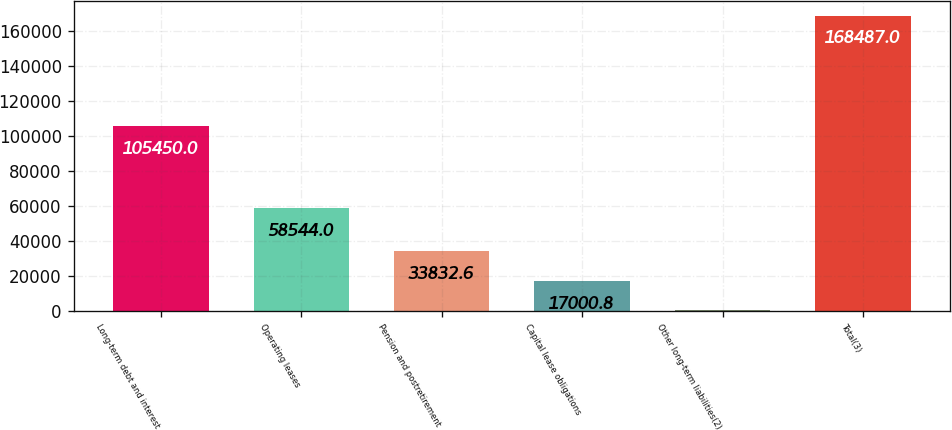<chart> <loc_0><loc_0><loc_500><loc_500><bar_chart><fcel>Long-term debt and interest<fcel>Operating leases<fcel>Pension and postretirement<fcel>Capital lease obligations<fcel>Other long-term liabilities(2)<fcel>Total(3)<nl><fcel>105450<fcel>58544<fcel>33832.6<fcel>17000.8<fcel>169<fcel>168487<nl></chart> 